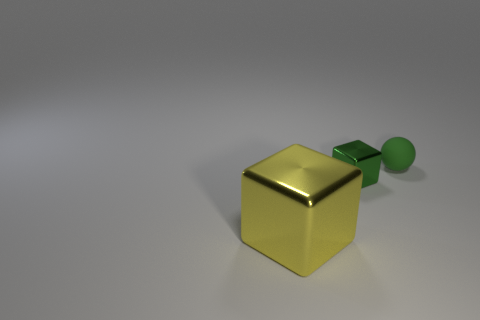How many objects are red blocks or cubes behind the yellow cube?
Offer a terse response. 1. The large metal thing has what color?
Give a very brief answer. Yellow. The block right of the metal block in front of the cube right of the big metallic cube is made of what material?
Provide a succinct answer. Metal. What size is the other block that is the same material as the yellow block?
Offer a terse response. Small. Is there a metallic ball that has the same color as the tiny cube?
Give a very brief answer. No. Is the size of the green cube the same as the object that is behind the green metallic cube?
Provide a succinct answer. Yes. What number of things are right of the block behind the metallic object that is in front of the tiny green metallic cube?
Offer a terse response. 1. There is a block that is the same color as the tiny matte object; what is its size?
Your answer should be very brief. Small. There is a green matte thing; are there any matte objects left of it?
Keep it short and to the point. No. The large metallic thing has what shape?
Your response must be concise. Cube. 